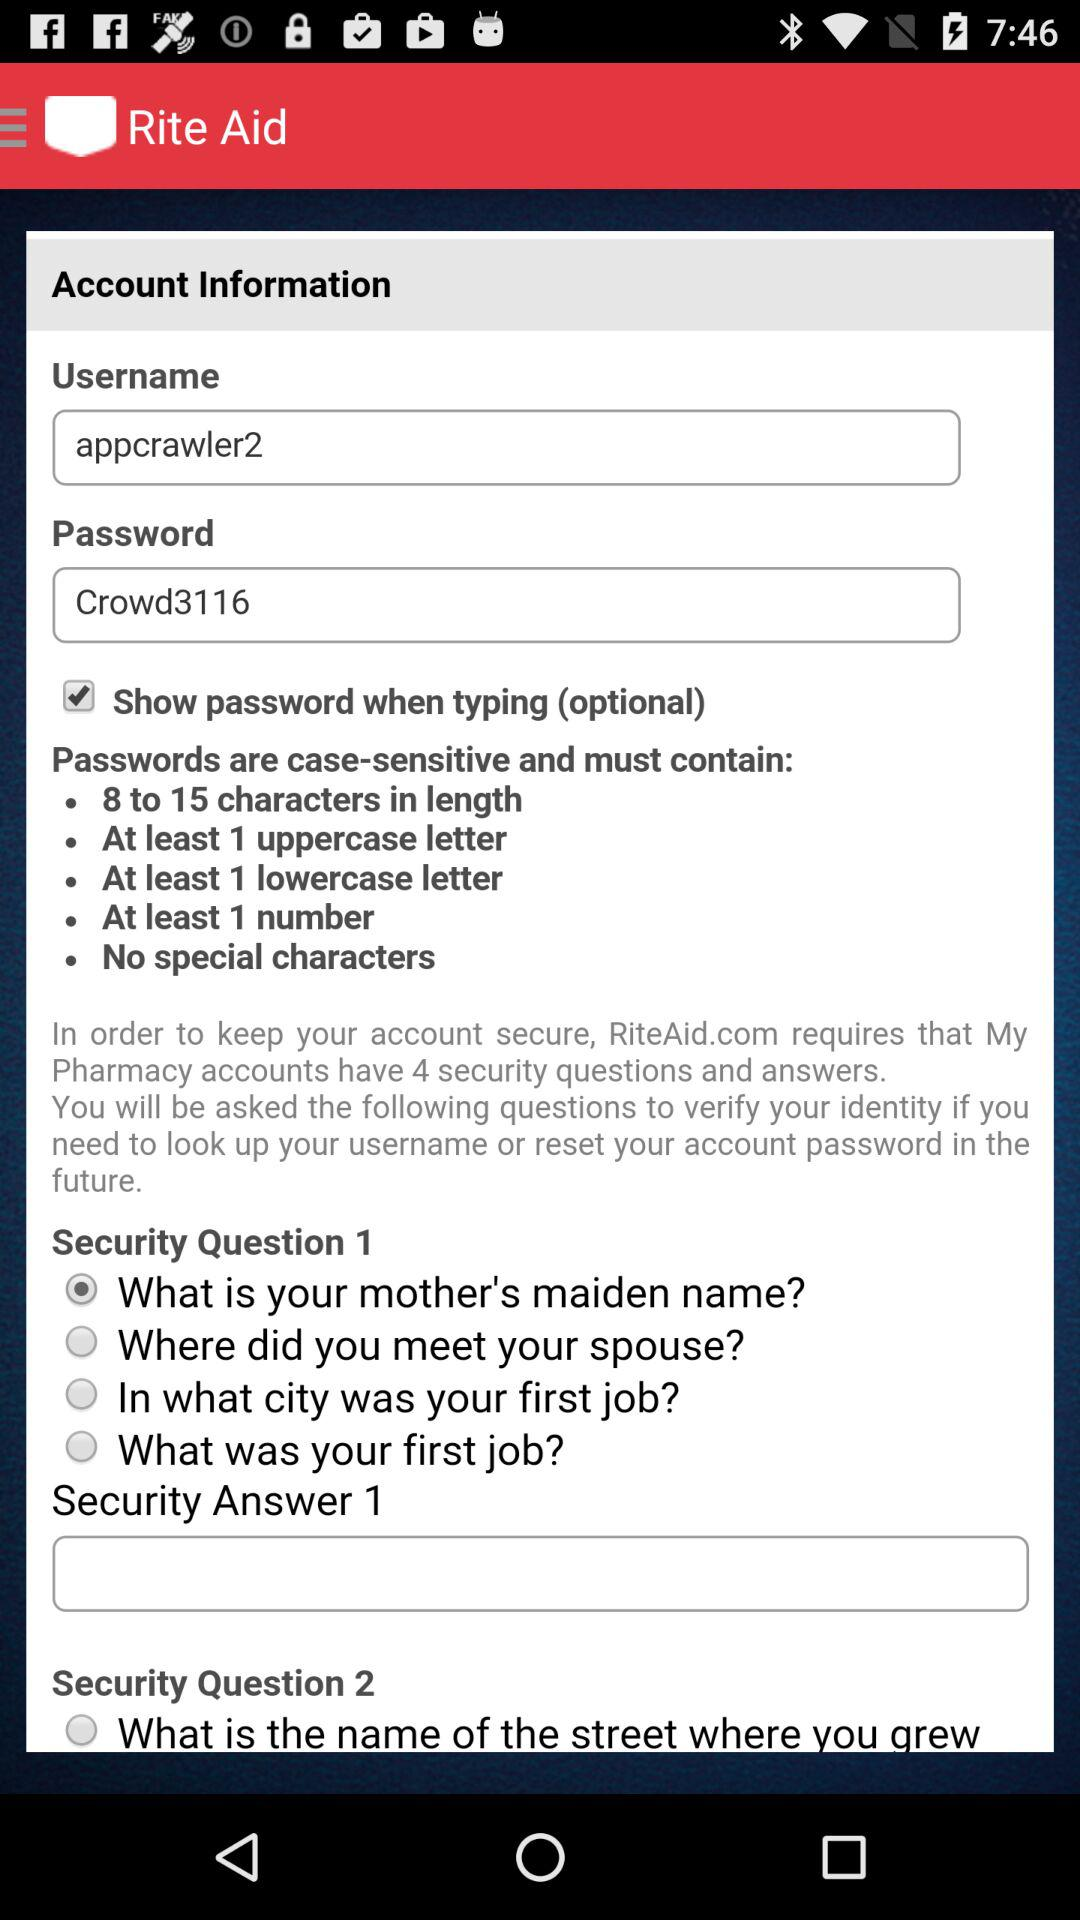How many special characters are required? There are no special characters required. 